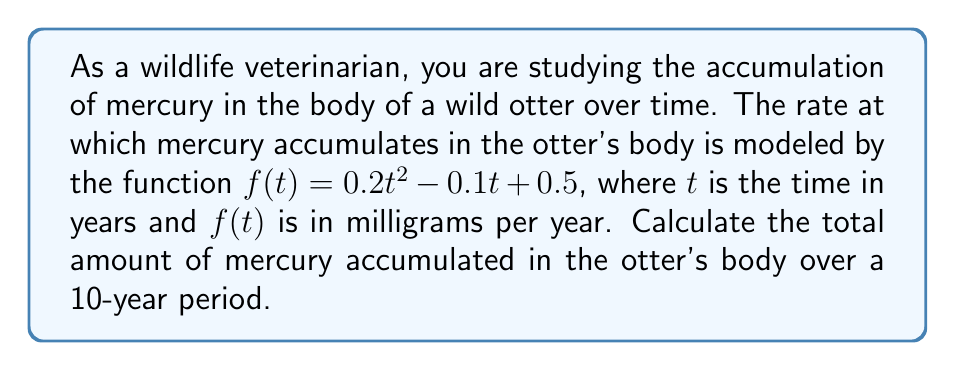Show me your answer to this math problem. To solve this problem, we need to compute the definite integral of the given function over the interval [0, 10]. This will give us the total accumulation of mercury over the 10-year period.

The function representing the rate of mercury accumulation is:
$$f(t) = 0.2t^2 - 0.1t + 0.5$$

To find the total accumulation, we need to integrate this function from 0 to 10:
$$\int_0^{10} (0.2t^2 - 0.1t + 0.5) dt$$

Let's integrate each term separately:

1. $\int 0.2t^2 dt = \frac{0.2t^3}{3}$
2. $\int -0.1t dt = -0.05t^2$
3. $\int 0.5 dt = 0.5t$

Now, let's combine these and apply the limits:

$$\left[\frac{0.2t^3}{3} - 0.05t^2 + 0.5t\right]_0^{10}$$

Evaluating at t = 10:
$$\frac{0.2(10^3)}{3} - 0.05(10^2) + 0.5(10) = 200 - 5 + 5 = 200$$

Evaluating at t = 0:
$$\frac{0.2(0^3)}{3} - 0.05(0^2) + 0.5(0) = 0$$

The difference gives us the total accumulation:
$$200 - 0 = 200$$

Therefore, the total amount of mercury accumulated in the otter's body over a 10-year period is 200 milligrams.
Answer: 200 milligrams 